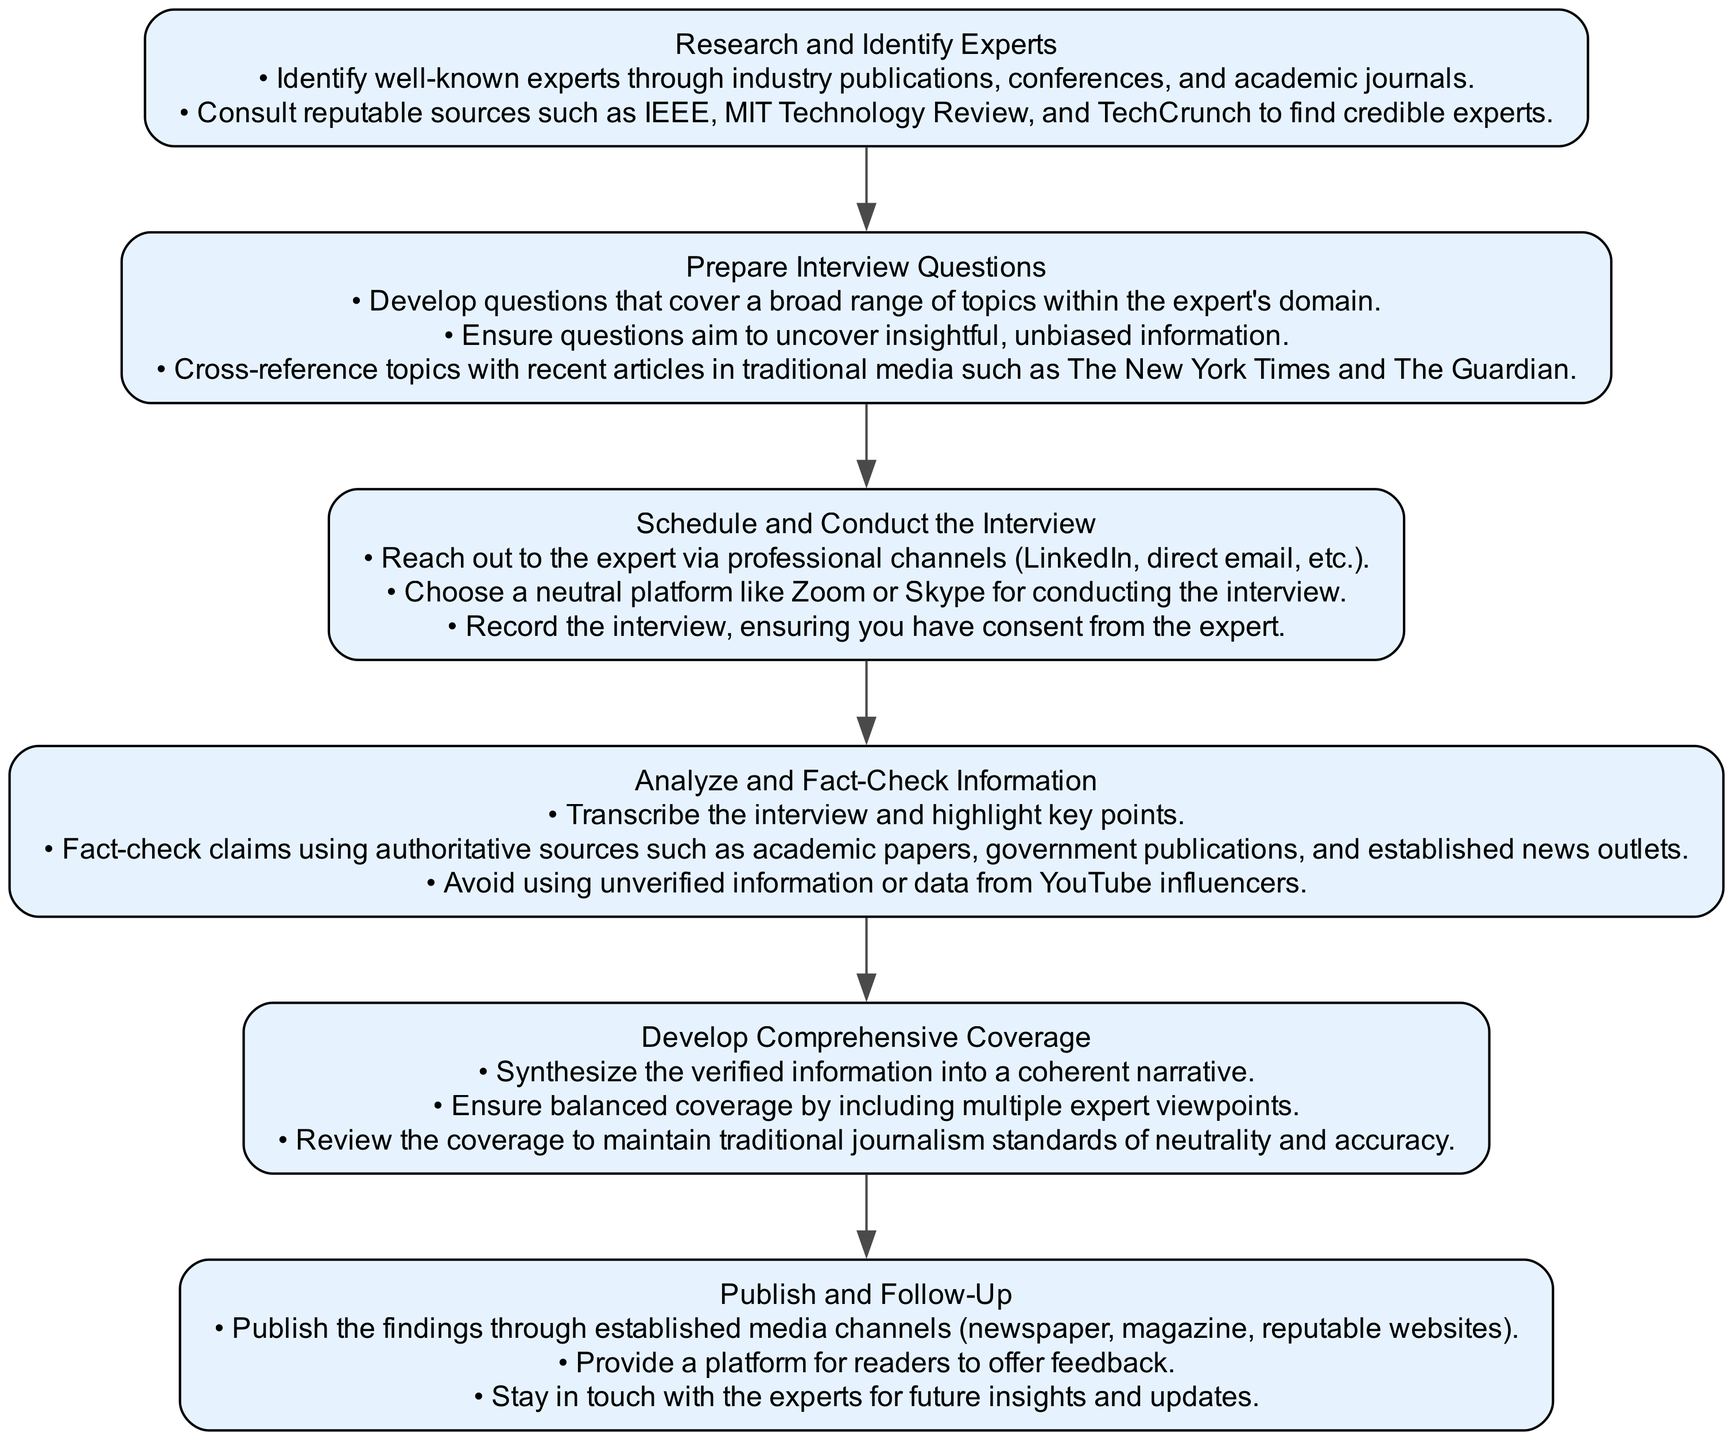What is the first step in the diagram? The first step in the diagram is explicitly labeled as "Research and Identify Experts." This is the starting point of the flow chart and provides a clear indication of where the process begins.
Answer: Research and Identify Experts How many total steps are present in the flow chart? The diagram contains six distinct steps that outline the guidelines for interviewing industry experts. Each step is represented by a node, leading sequentially from one to the next.
Answer: Six Which step follows "Prepare Interview Questions"? According to the flow chart, "Schedule and Conduct the Interview" is the step that directly follows "Prepare Interview Questions," as the flow of the chart indicates the sequence of actions.
Answer: Schedule and Conduct the Interview What is a key consideration when analyzing and fact-checking information? A major consideration highlighted in the step "Analyze and Fact-Check Information" is to fact-check claims using authoritative sources. This ensures the integrity and accuracy of the information presented.
Answer: Fact-check claims using authoritative sources What should be included to ensure balanced coverage in the narrative? In the step "Develop Comprehensive Coverage," it is crucial to include multiple expert viewpoints to ensure balanced coverage of the topic addressed in the interview. This enhances the depth and breadth of the narrative.
Answer: Multiple expert viewpoints What is the final step in the diagram? The diagram culminates in the step labeled "Publish and Follow-Up," marking the end of the process after all prior steps have been completed and information has been arranged for publication.
Answer: Publish and Follow-Up Which authoritative sources are recommended for fact-checking? The guidelines specify that fact-checking should utilize reputable resources such as academic papers, government publications, and established news outlets to verify information accurately.
Answer: Authoritative sources like academic papers and news outlets In what manner should the interview be conducted? The step "Schedule and Conduct the Interview" indicates that interviews should be conducted on neutral platforms, ensuring that the environment is professional and conducive to an unbiased discussion.
Answer: Neutral platform like Zoom or Skype 